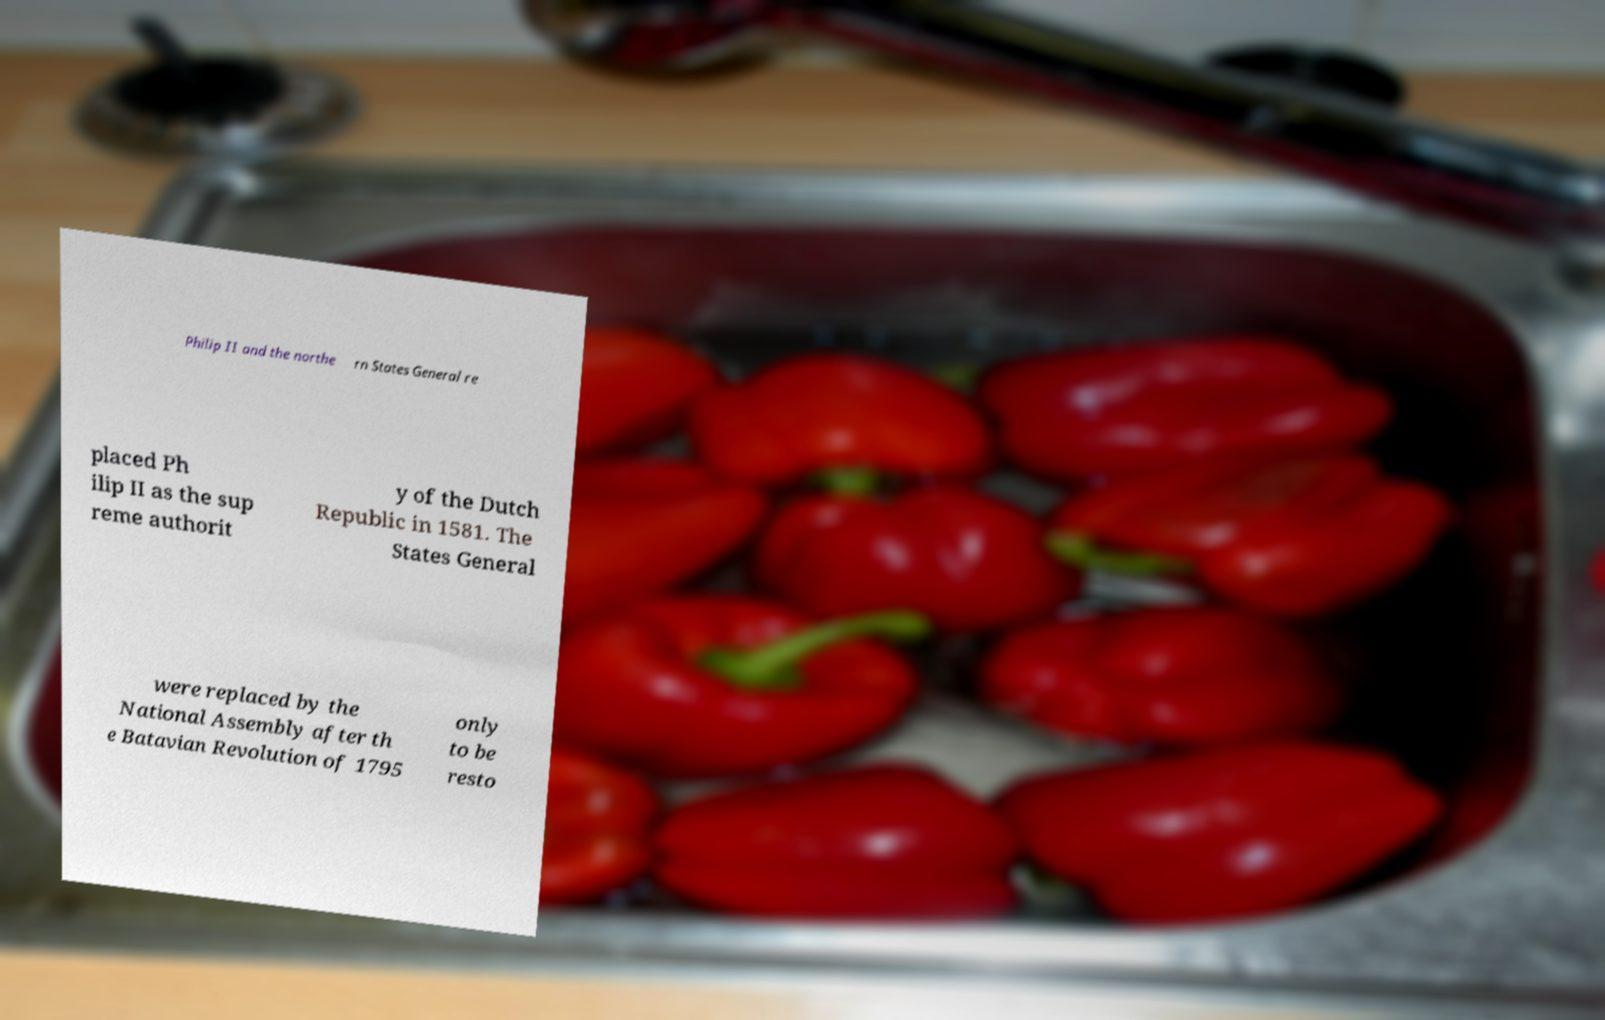What messages or text are displayed in this image? I need them in a readable, typed format. Philip II and the northe rn States General re placed Ph ilip II as the sup reme authorit y of the Dutch Republic in 1581. The States General were replaced by the National Assembly after th e Batavian Revolution of 1795 only to be resto 